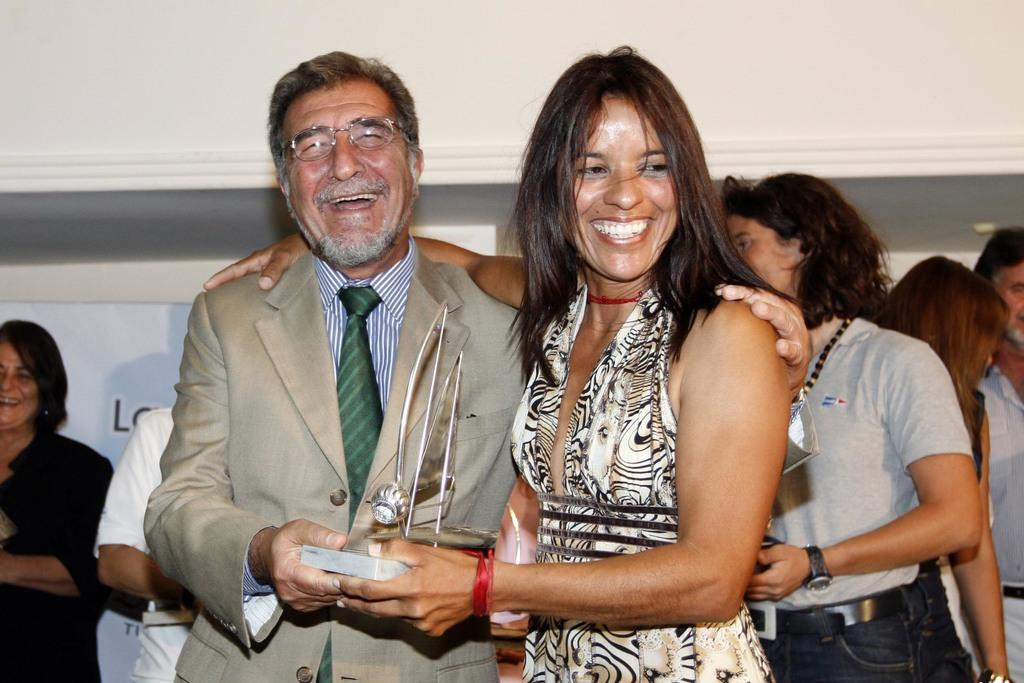Who are the two people in the center of the image? There is a man and a woman in the center of the image. What are the man and woman holding? The man and woman are holding a trophy. Can you describe the background of the image? There are persons and an advertisement in the background of the image, as well as a wall. What type of button does the spy use to communicate with their team in the image? There is no spy or button present in the image. 